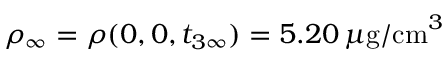Convert formula to latex. <formula><loc_0><loc_0><loc_500><loc_500>\rho _ { \infty } = \rho ( 0 , 0 , t _ { 3 \infty } ) = 5 . 2 0 \, \mu g / c m ^ { 3 }</formula> 